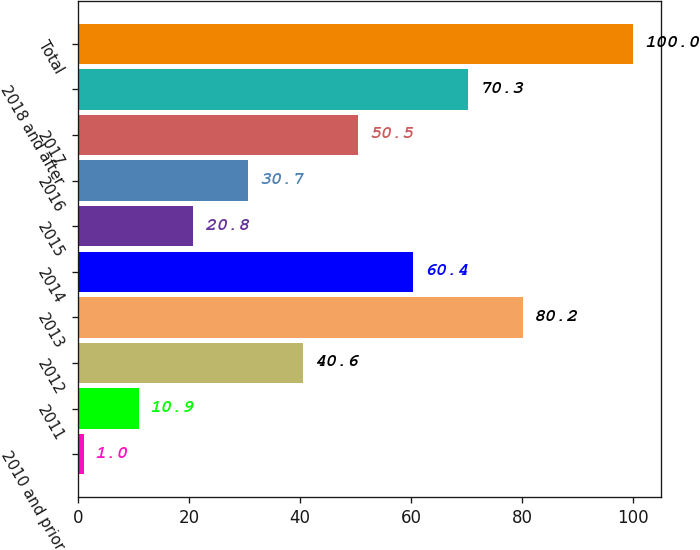<chart> <loc_0><loc_0><loc_500><loc_500><bar_chart><fcel>2010 and prior<fcel>2011<fcel>2012<fcel>2013<fcel>2014<fcel>2015<fcel>2016<fcel>2017<fcel>2018 and after<fcel>Total<nl><fcel>1<fcel>10.9<fcel>40.6<fcel>80.2<fcel>60.4<fcel>20.8<fcel>30.7<fcel>50.5<fcel>70.3<fcel>100<nl></chart> 